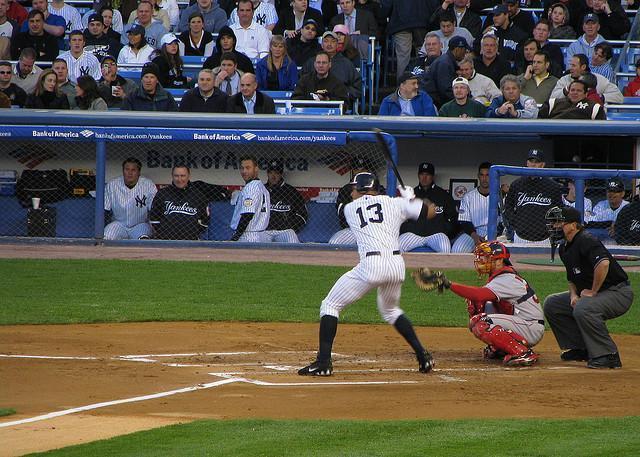How many people are there?
Give a very brief answer. 9. How many us airways express airplanes are in this image?
Give a very brief answer. 0. 